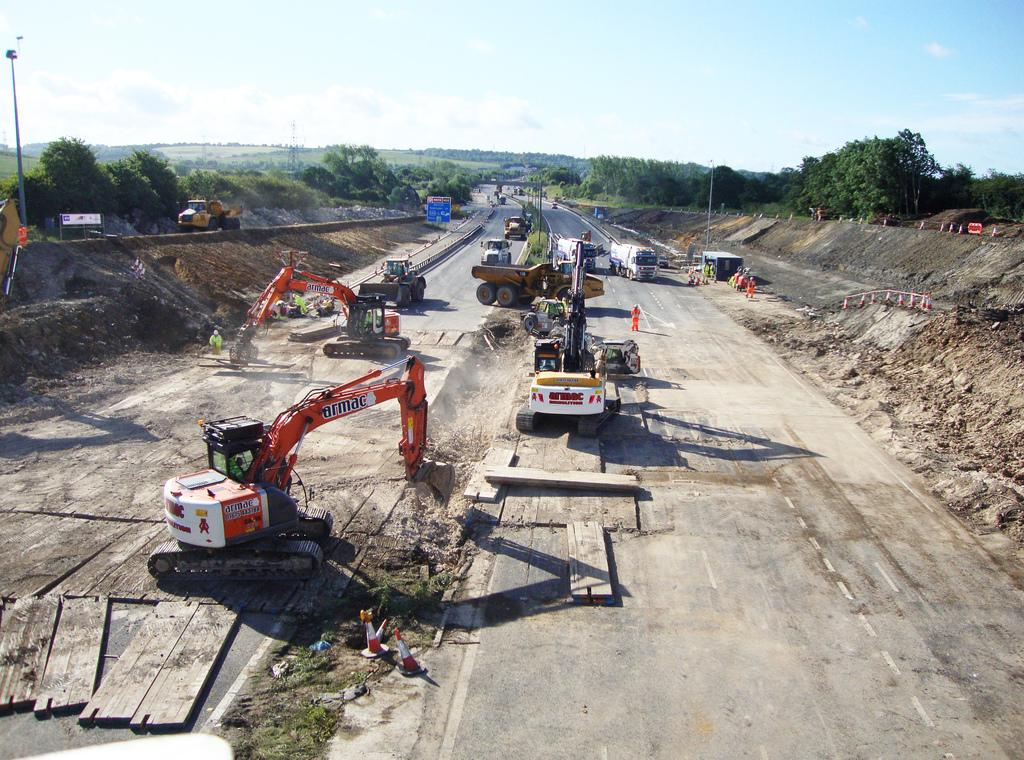Provide a one-sentence caption for the provided image. An armac excavator is at work doing site work. 